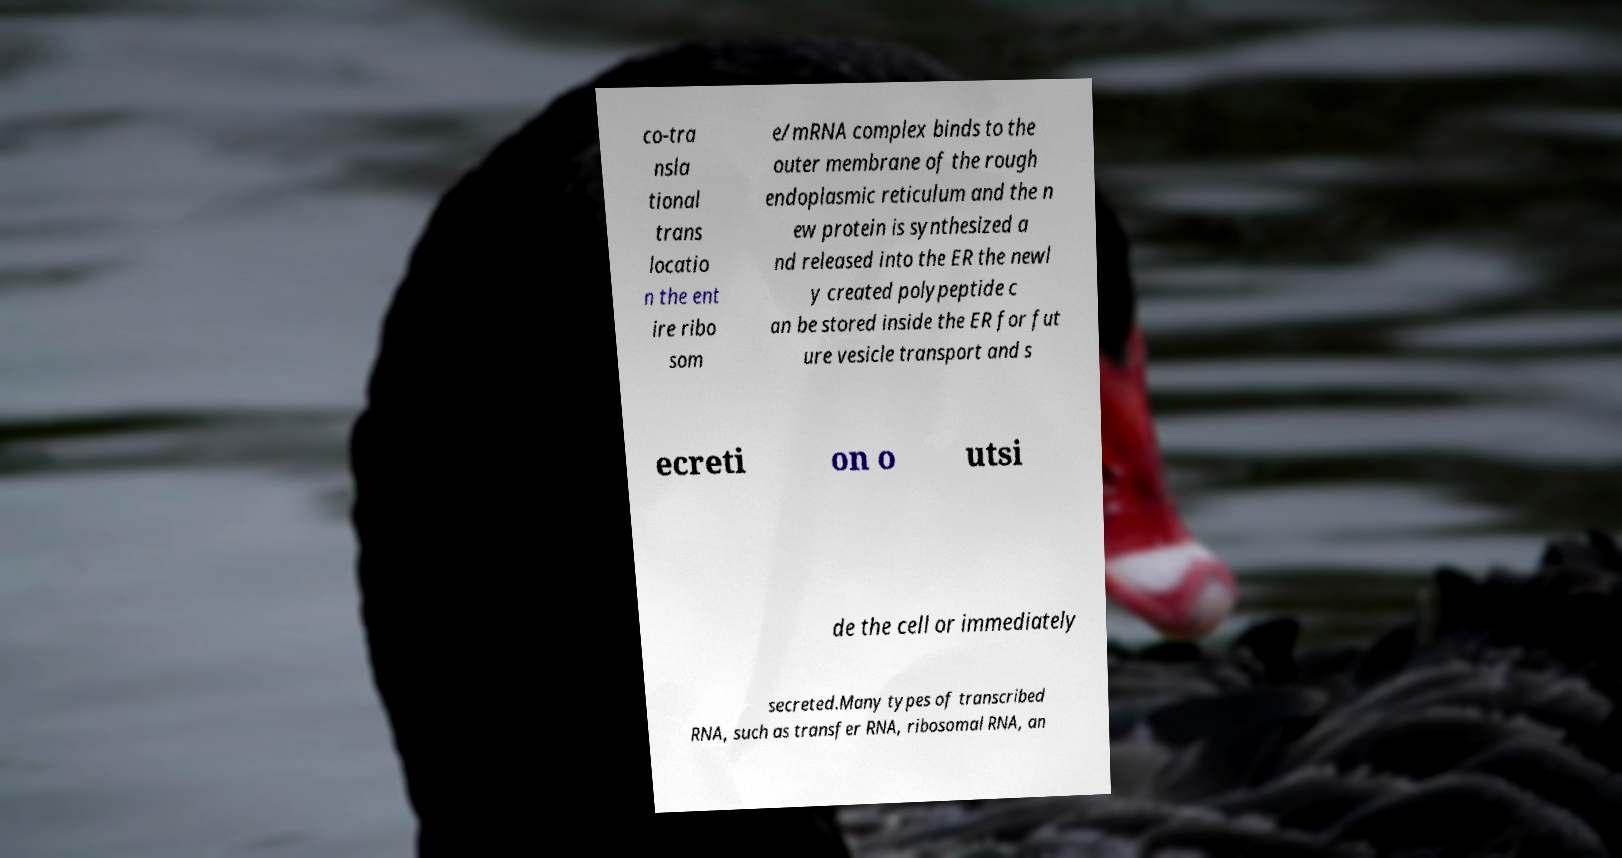Could you extract and type out the text from this image? co-tra nsla tional trans locatio n the ent ire ribo som e/mRNA complex binds to the outer membrane of the rough endoplasmic reticulum and the n ew protein is synthesized a nd released into the ER the newl y created polypeptide c an be stored inside the ER for fut ure vesicle transport and s ecreti on o utsi de the cell or immediately secreted.Many types of transcribed RNA, such as transfer RNA, ribosomal RNA, an 